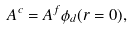Convert formula to latex. <formula><loc_0><loc_0><loc_500><loc_500>A ^ { c } = A ^ { f } \phi _ { d } ( r = 0 ) ,</formula> 